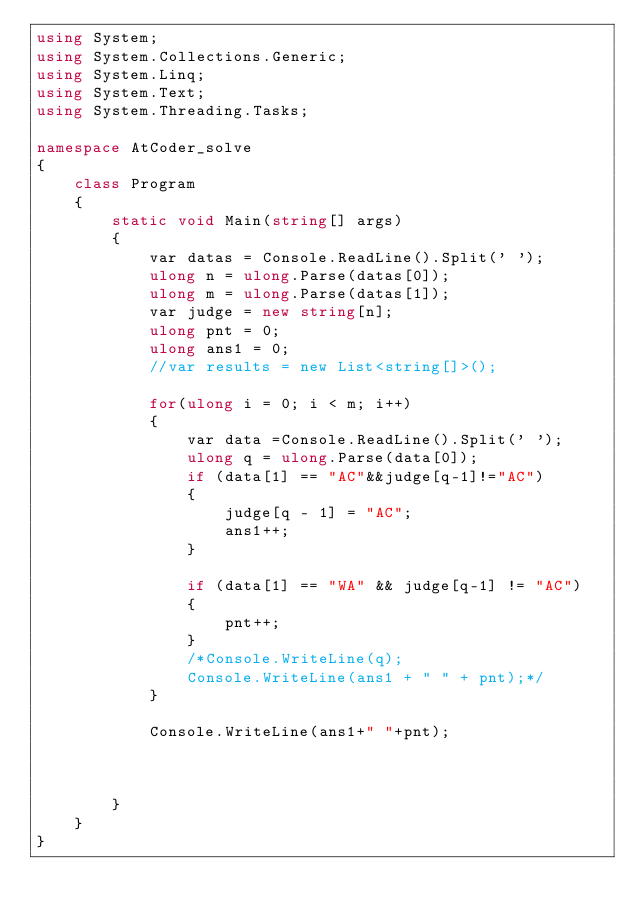Convert code to text. <code><loc_0><loc_0><loc_500><loc_500><_C#_>using System;
using System.Collections.Generic;
using System.Linq;
using System.Text;
using System.Threading.Tasks;

namespace AtCoder_solve
{
    class Program
    {
        static void Main(string[] args)
        {
            var datas = Console.ReadLine().Split(' ');
            ulong n = ulong.Parse(datas[0]);
            ulong m = ulong.Parse(datas[1]);
            var judge = new string[n];
            ulong pnt = 0;
            ulong ans1 = 0;
            //var results = new List<string[]>();

            for(ulong i = 0; i < m; i++)
            {
                var data =Console.ReadLine().Split(' ');
                ulong q = ulong.Parse(data[0]);
                if (data[1] == "AC"&&judge[q-1]!="AC")
                {
                    judge[q - 1] = "AC";
                    ans1++;
                }

                if (data[1] == "WA" && judge[q-1] != "AC")
                {
                    pnt++;
                }
                /*Console.WriteLine(q);
                Console.WriteLine(ans1 + " " + pnt);*/
            }

            Console.WriteLine(ans1+" "+pnt);



        }
    }
}
</code> 